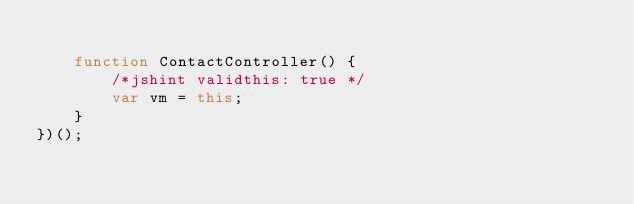<code> <loc_0><loc_0><loc_500><loc_500><_JavaScript_>
    function ContactController() {
        /*jshint validthis: true */
		var vm = this;
	}
})();</code> 